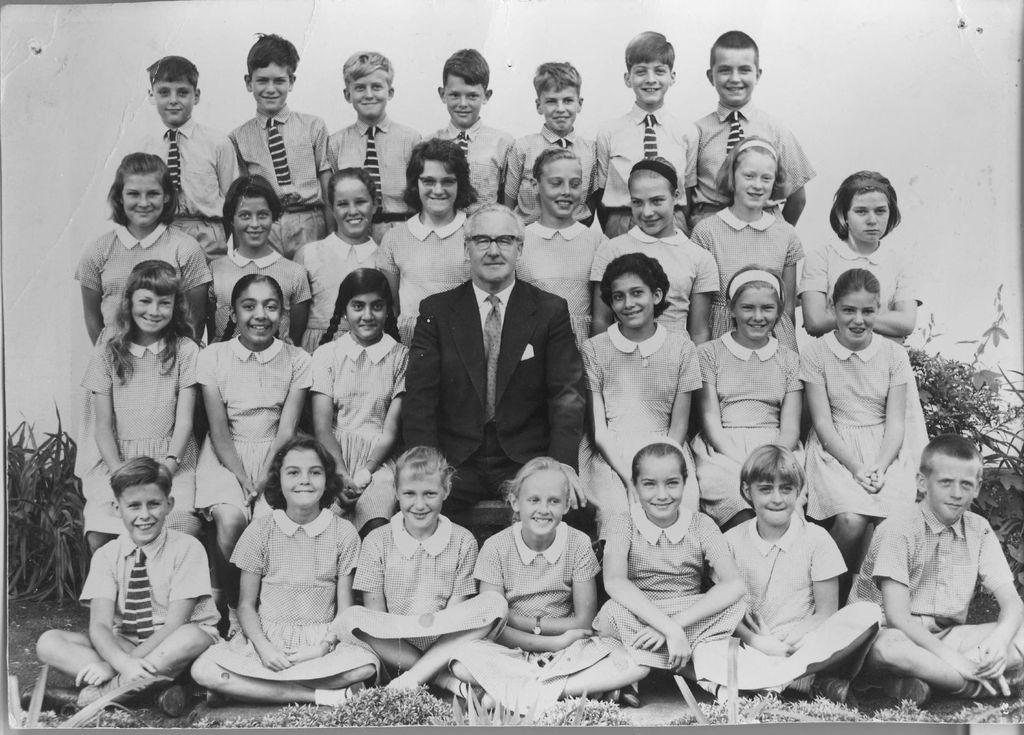Could you give a brief overview of what you see in this image? This is a black and white image. In the center of the image there is a person wearing a suit. Beside him there are children. In the background of the image there is a wall. There are plants. 